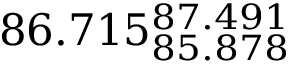Convert formula to latex. <formula><loc_0><loc_0><loc_500><loc_500>8 6 . 7 1 5 _ { 8 5 . 8 7 8 } ^ { 8 7 . 4 9 1 }</formula> 